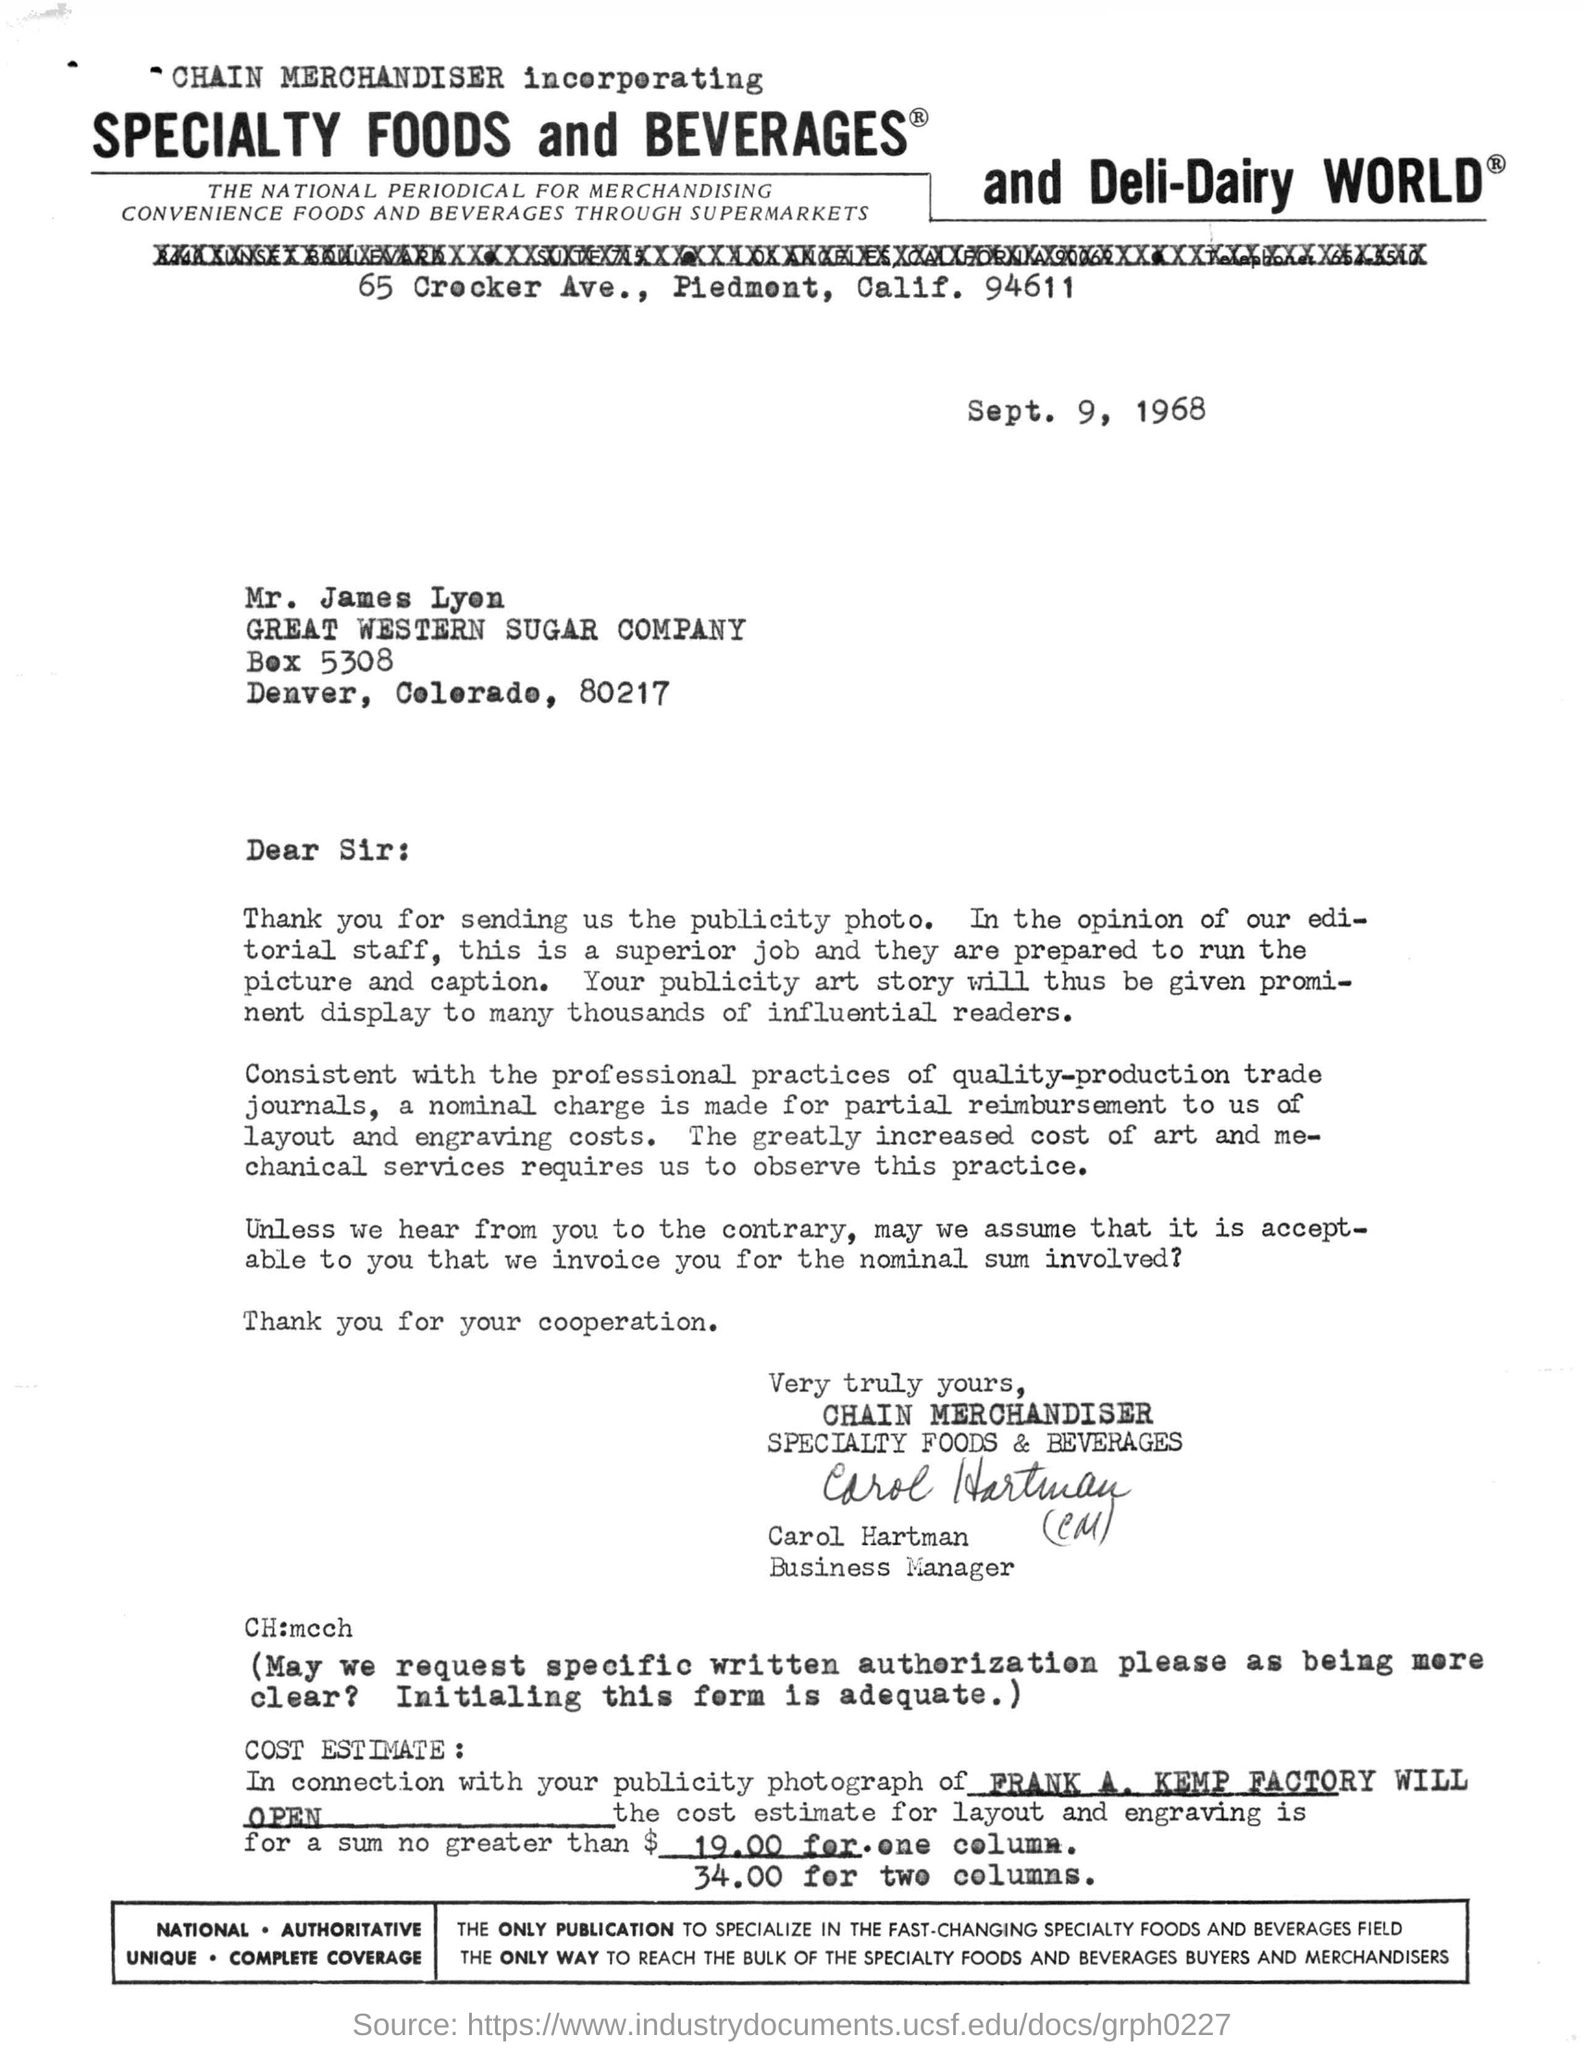On which date this letter was written ?
Your answer should be compact. Sept. 9 ,1968. Who has signed the letter ?
Ensure brevity in your answer.  BUSINESS MANAGER. What is the estimated cost for layout and engraving for one column ?
Your answer should be very brief. $ 19.00. To whom this letter was written ?
Give a very brief answer. Mr. James Lyen. What is the estimated cost for layout and engraving for two columns ?
Your answer should be very brief. $ 34.00. 